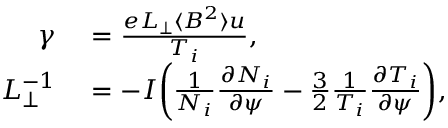Convert formula to latex. <formula><loc_0><loc_0><loc_500><loc_500>\begin{array} { r l } { \gamma } & = \frac { e L _ { \perp } \langle B ^ { 2 } \rangle u } { T _ { i } } , } \\ { L _ { \perp } ^ { - 1 } } & = - I \left ( \frac { 1 } { N _ { i } } \frac { \partial N _ { i } } { \partial \psi } - \frac { 3 } { 2 } \frac { 1 } { T _ { i } } \frac { \partial T _ { i } } { \partial \psi } \right ) , } \end{array}</formula> 